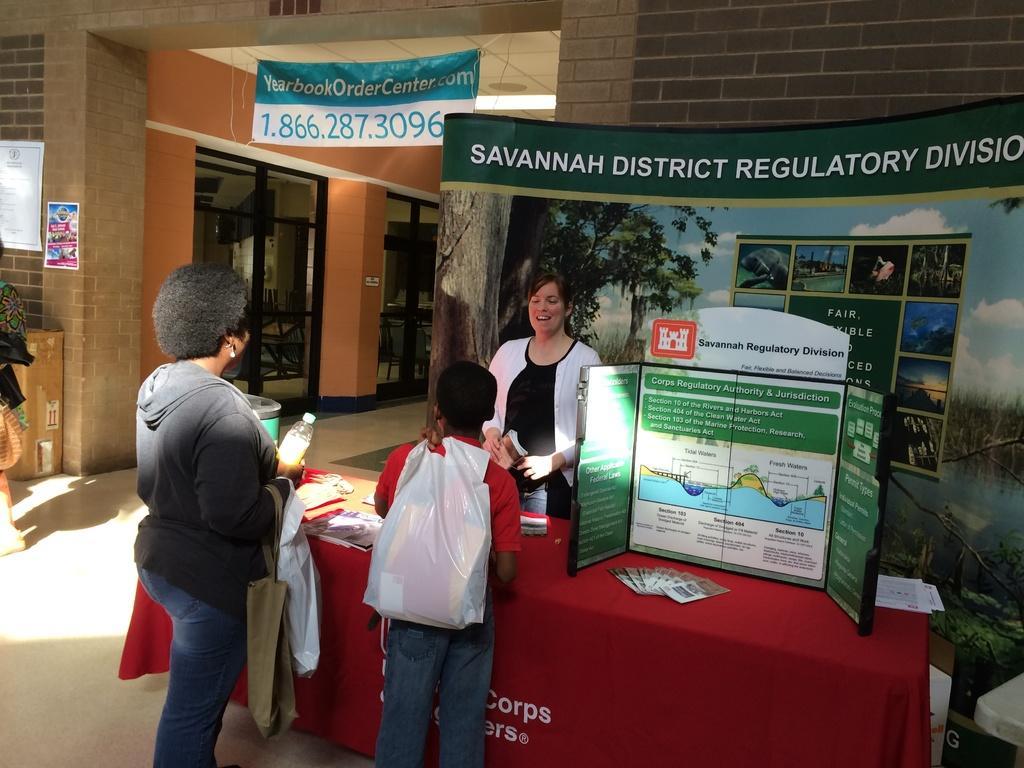Can you describe this image briefly? In this picture we can see few people on the ground, here we can see a table, banner, posters and some objects and in the background we can see a building. 